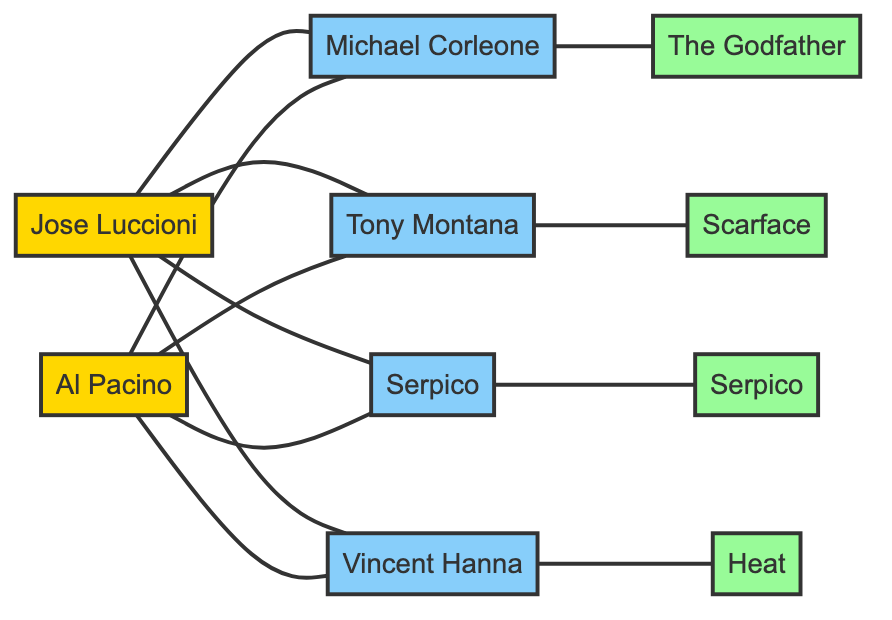What character is dubbed by Jose Luccioni from The Godfather? To find the character dubbed by Jose Luccioni from The Godfather, we look for an edge between Jose Luccioni and a character node. The edge connects Jose Luccioni to Michael Corleone, who is linked to The Godfather.
Answer: Michael Corleone How many movies are featured in the graph? The graph contains nodes labeled as movies; we count the unique movie nodes: The Godfather, Scarface, Heat, and Serpico. This gives a total of 4 movie nodes.
Answer: 4 Who plays Tony Montana? The diagram shows a connection between Al Pacino and the character node Tony Montana. Therefore, Al Pacino plays this character.
Answer: Al Pacino What is the relationship between Jose Luccioni and Vincent Hanna? The edge connecting Jose Luccioni and Vincent Hanna is labeled as "Dubs", indicating that Jose Luccioni provides the dubbing for Vincent Hanna in films.
Answer: Dubs Which character is from the movie Scarface? By examining the edges, we find Tony Montana is linked to the movie node Scarface, indicating he is a character from this movie.
Answer: Tony Montana How many characters does Jose Luccioni dub? We count the edges coming from Jose Luccioni to various character nodes. There are four edges: one to Michael Corleone, one to Tony Montana, one to Serpico, and one to Vincent Hanna, totaling four characters.
Answer: 4 Which movie is associated with the character Serpico? The edge connecting Serpico to the node labeled SerpicoMovie indicates that the character Serpico is associated with the movie of the same name.
Answer: Serpico What character is associated with the movie Heat? The node for Heat is connected to the character node Vincent Hanna. Thus, Vincent Hanna is the character associated with the movie Heat.
Answer: Vincent Hanna 